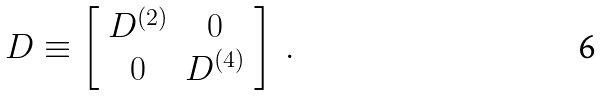Convert formula to latex. <formula><loc_0><loc_0><loc_500><loc_500>D \equiv \left [ \begin{array} { c c } D ^ { ( 2 ) } & 0 \\ 0 & D ^ { ( 4 ) } \end{array} \right ] \ .</formula> 